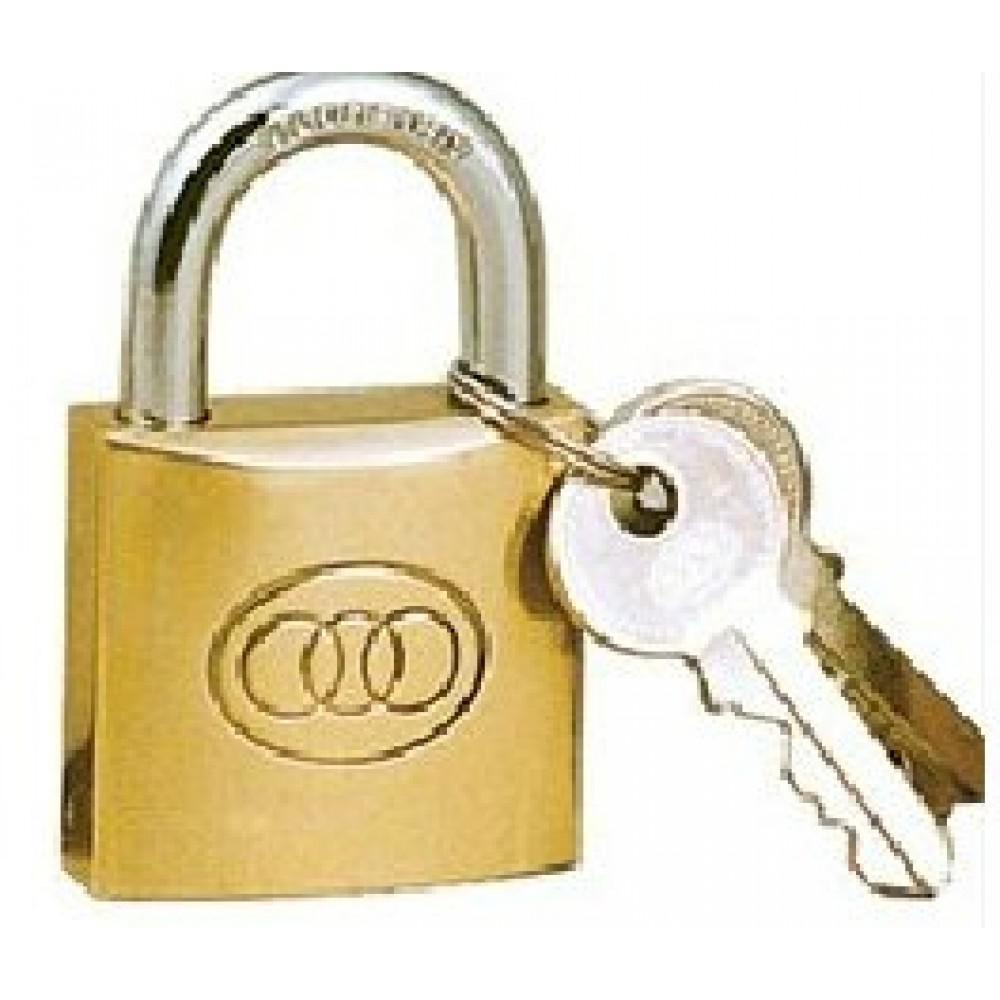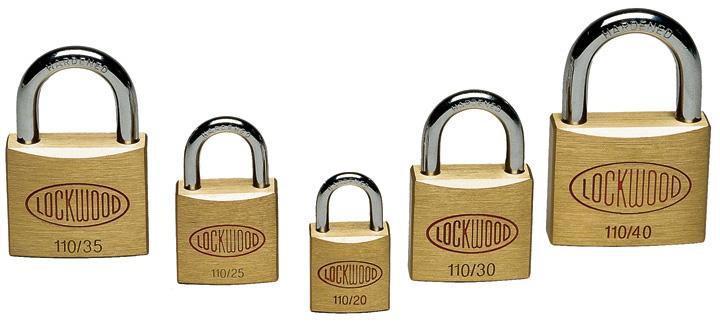The first image is the image on the left, the second image is the image on the right. Analyze the images presented: Is the assertion "There are exactly six keys." valid? Answer yes or no. No. The first image is the image on the left, the second image is the image on the right. Analyze the images presented: Is the assertion "Each image contains exactly three keys and only gold-bodied locks." valid? Answer yes or no. No. 